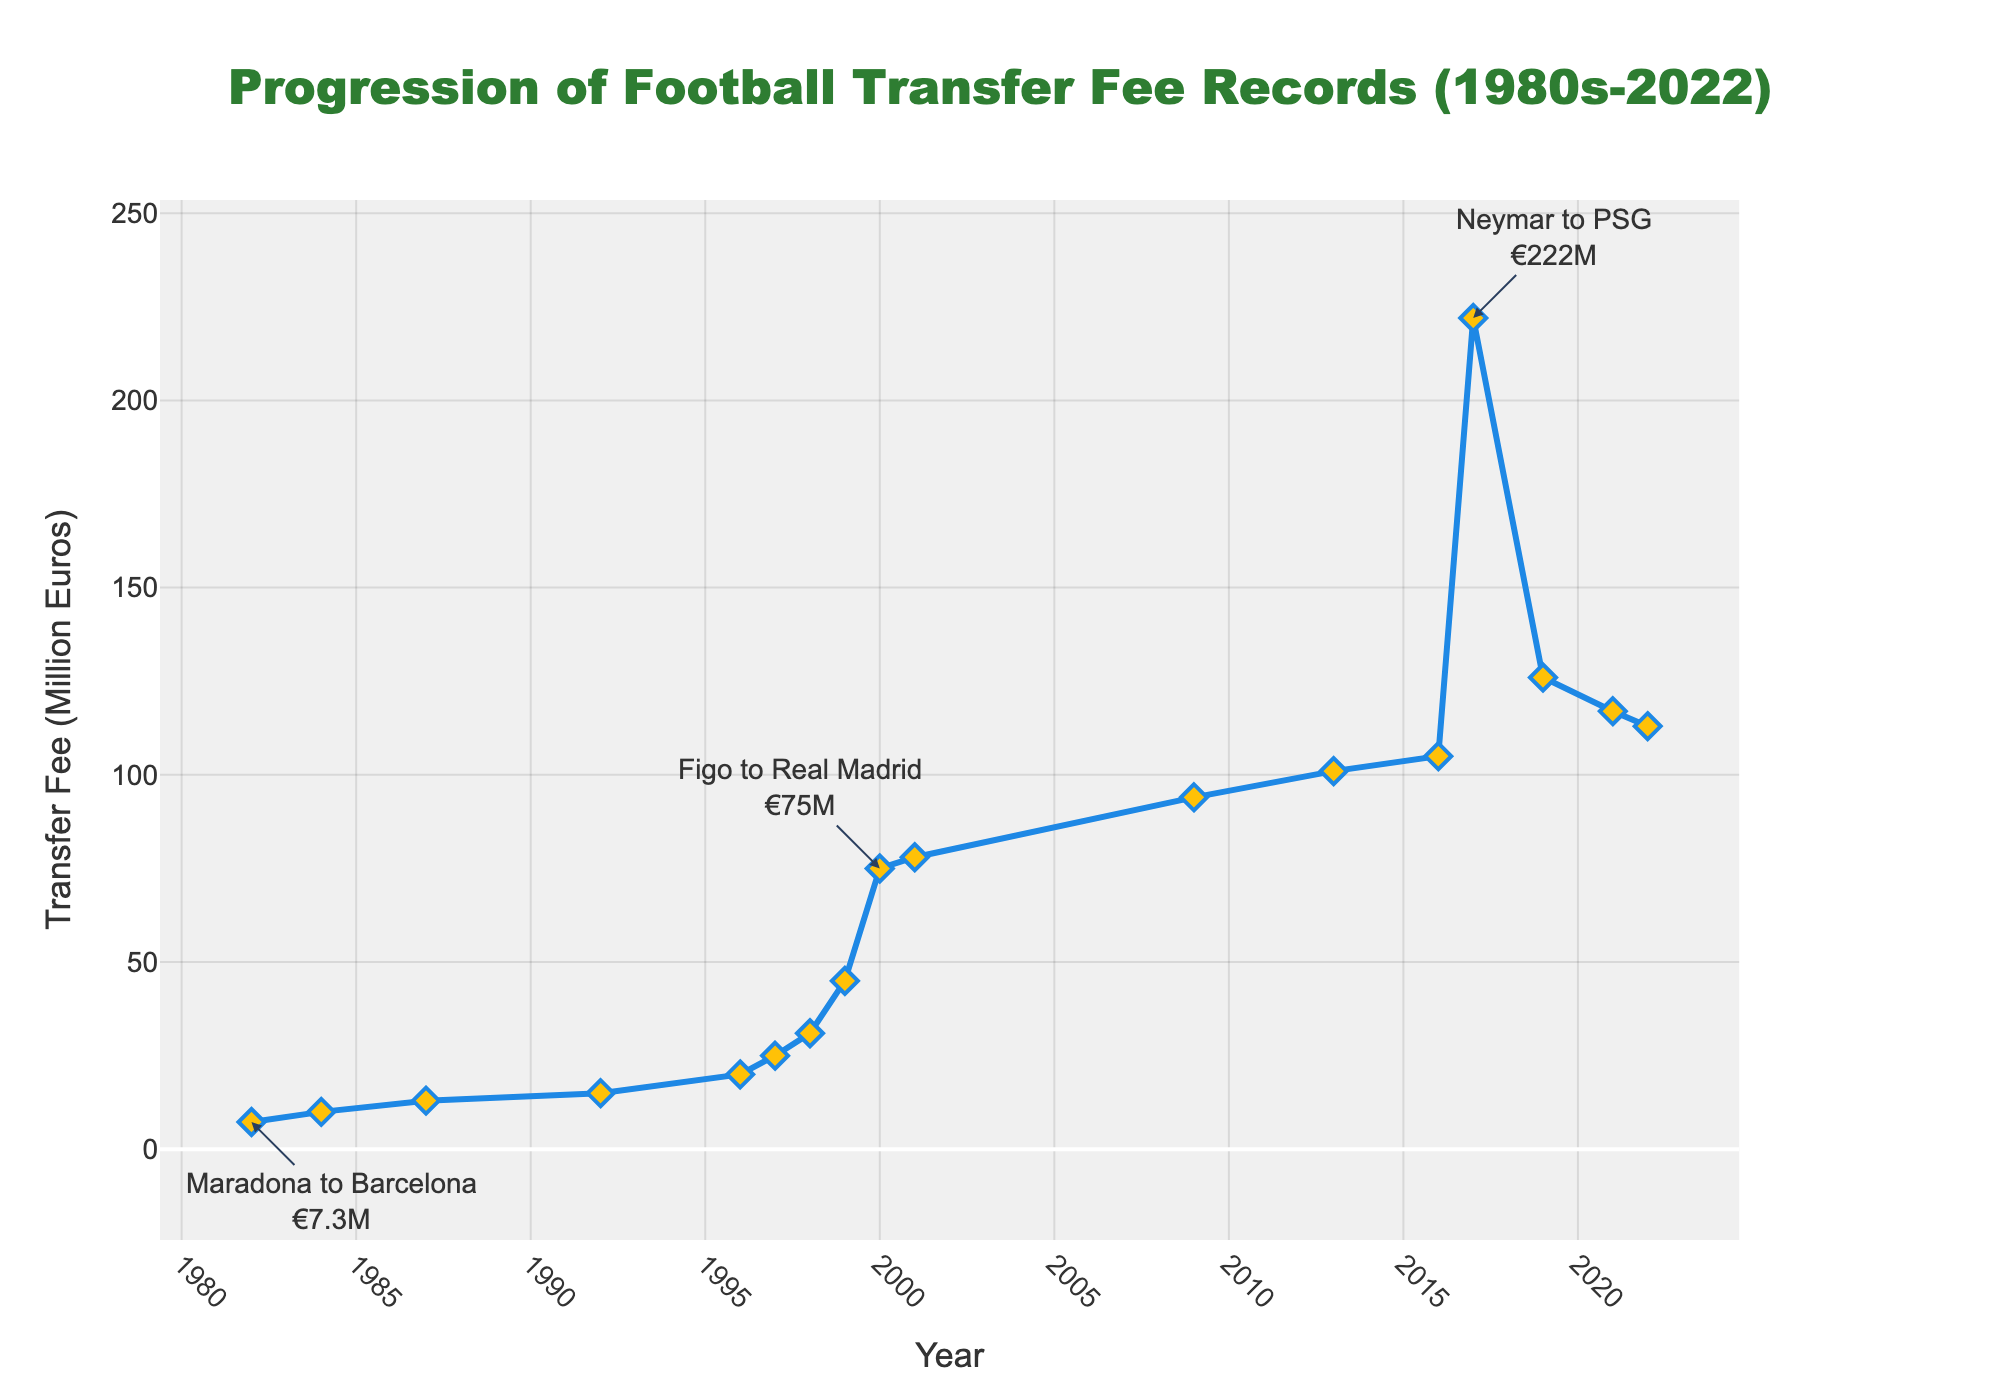What was the transfer fee in 2000? Locate the year 2000 on the x-axis and find the corresponding y-value. The transfer fee in 2000 was €75 million.
Answer: €75 million Which year saw the highest transfer fee, and what was the fee? Identify the highest point on the line chart and find the year associated with it. The year is 2017, and the transfer fee was €222 million.
Answer: 2017, €222 million How much did the transfer fee increase from 1982 to 2000? Find the transfer fees for the years 1982 and 2000, which are €7.3 million and €75 million respectively. Subtract the earlier fee from the later one: €75 million - €7.3 million = €67.7 million.
Answer: €67.7 million By how much did the transfer fee decrease from 2017 to 2022? Find the transfer fees for the years 2017 and 2022, which are €222 million and €113 million respectively. Subtract the later fee from the earlier one: €222 million - €113 million = €109 million.
Answer: €109 million What trend do you observe in transfer fees from the 1980s to 2022? Transfer fees generally increased over the time period, with occasional decreases. The largest increase is seen around 2017.
Answer: Generally increasing with occasional decreases How did the transfer fee change from 1992 to 2000? Find the transfer fees for the years 1992 and 2000, which are €15 million and €75 million respectively. Subtract the earlier fee from the later one: €75 million - €15 million = €60 million.
Answer: €60 million increase What can be inferred from the transfer fee progression in 1999 and 2000? In 1999, the fee was €45 million, and in 2000, it jumped to €75 million. This indicates a significant increase within a year.
Answer: Significant increase within a year Compare the transfer fees of 2001 and 2016. Which year had a higher fee? Locate both years on the x-axis, and compare their y-values. 2001 had a fee of €78 million, while 2016 had a fee of €105 million. The fee was higher in 2016.
Answer: 2016 What significant event is annotated for the year 1982? The annotation for 1982 mentions "Maradona to Barcelona" with a transfer fee of €7.3 million.
Answer: Maradona to Barcelona, €7.3 million Which years saw the transfer fees surpass €100 million for the first time? On the y-axis, locate the point where the transfer fee first surpasses €100 million. This happens in 2013 with a fee of €101 million.
Answer: 2013 